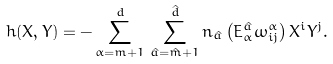<formula> <loc_0><loc_0><loc_500><loc_500>h ( X , Y ) = - \sum _ { \alpha = m + 1 } ^ { d } \, \sum _ { \hat { a } = \hat { m } + 1 } ^ { \hat { d } } n _ { \hat { a } } \left ( E ^ { \hat { a } } _ { \alpha } \omega ^ { \alpha } _ { i j } \right ) X ^ { i } Y ^ { j } .</formula> 